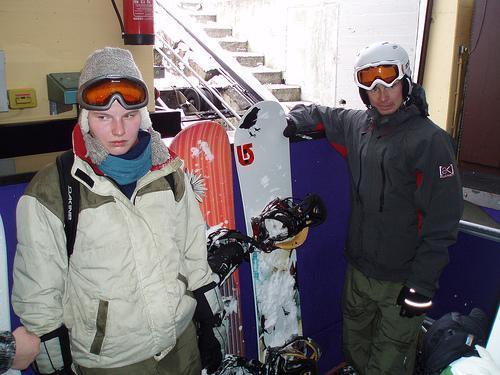How many people are in the photo?
Give a very brief answer. 2. How many snowboards are there?
Give a very brief answer. 2. How many women are wearing helmets?
Give a very brief answer. 0. 